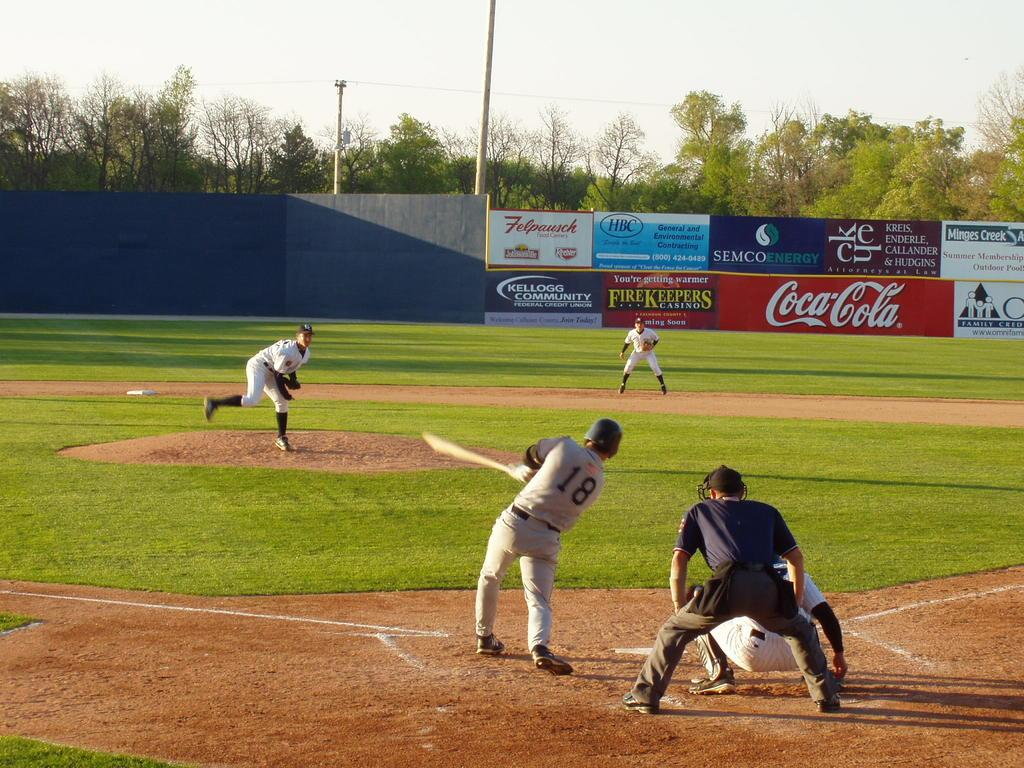<image>
Provide a brief description of the given image. The baseball stadium is sponsored by Coca-Cola and Semco Energy. 